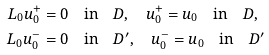<formula> <loc_0><loc_0><loc_500><loc_500>L _ { 0 } u _ { 0 } ^ { + } & = 0 \quad \text {in} \quad D , \quad u _ { 0 } ^ { + } = u _ { 0 } \quad \text {in} \quad D , \\ L _ { 0 } u _ { 0 } ^ { - } & = 0 \quad \text {in} \quad D ^ { \prime } , \quad u _ { 0 } ^ { - } = u _ { 0 } \quad \text {in} \quad D ^ { \prime }</formula> 